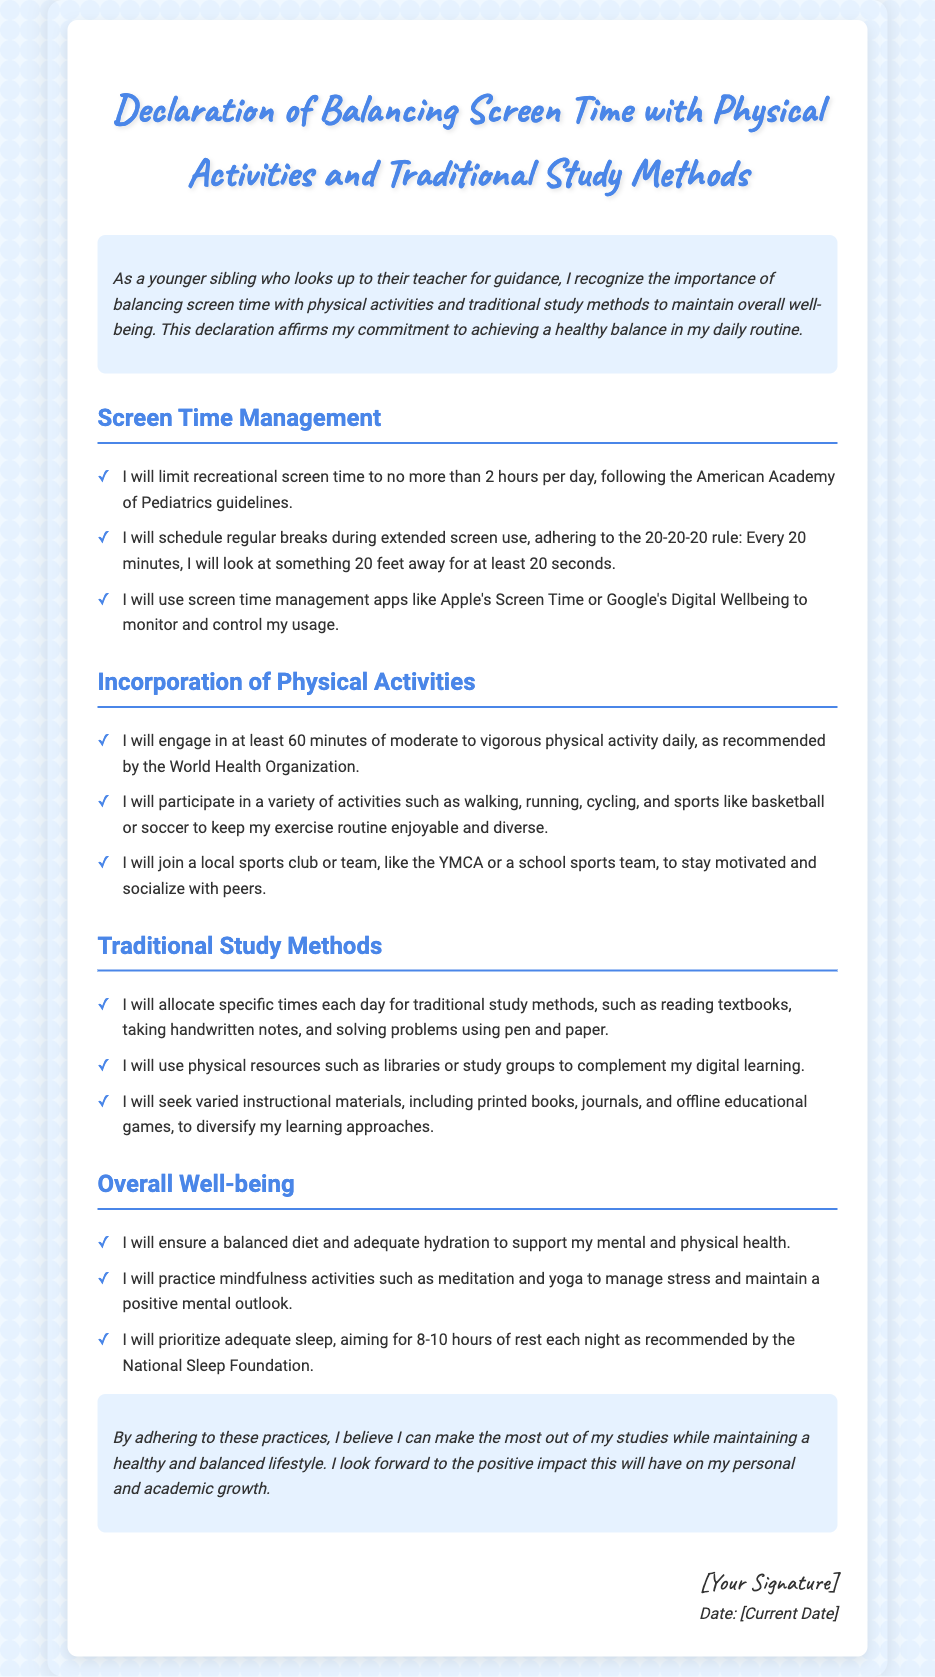what is the title of the document? The title is located at the top of the document and indicates what the document is about.
Answer: Declaration of Balancing Screen Time with Physical Activities and Traditional Study Methods how many hours of recreational screen time is recommended per day? The recommended limit for recreational screen time is mentioned in the section about Screen Time Management.
Answer: 2 hours what does the 20-20-20 rule involve? The 20-20-20 rule is described in the Screen Time Management section, explaining how to take breaks.
Answer: Look at something 20 feet away for at least 20 seconds how many minutes of physical activity should one engage in daily? The recommended amount of physical activity is highlighted in the Incorporation of Physical Activities section.
Answer: 60 minutes what are two activities mentioned for physical exercise? The document lists activities to include for variety in exercise routines, found in the Incorporation of Physical Activities section.
Answer: Walking, running what traditional study method involves solving problems? This method is specified in the Traditional Study Methods section and emphasizes a particular style of study.
Answer: Using pen and paper what is emphasized for overall well-being besides physical activities? This aspect is detailed in the Overall Well-being section, highlighting additional elements that contribute to health.
Answer: Mindfulness activities what is the target sleep duration per night? The target sleep duration is noted in the Overall Well-being section, addressing the amount of rest needed.
Answer: 8-10 hours 